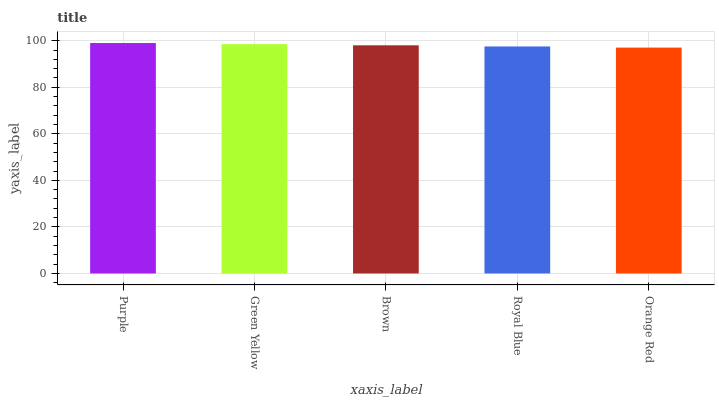Is Orange Red the minimum?
Answer yes or no. Yes. Is Purple the maximum?
Answer yes or no. Yes. Is Green Yellow the minimum?
Answer yes or no. No. Is Green Yellow the maximum?
Answer yes or no. No. Is Purple greater than Green Yellow?
Answer yes or no. Yes. Is Green Yellow less than Purple?
Answer yes or no. Yes. Is Green Yellow greater than Purple?
Answer yes or no. No. Is Purple less than Green Yellow?
Answer yes or no. No. Is Brown the high median?
Answer yes or no. Yes. Is Brown the low median?
Answer yes or no. Yes. Is Green Yellow the high median?
Answer yes or no. No. Is Orange Red the low median?
Answer yes or no. No. 